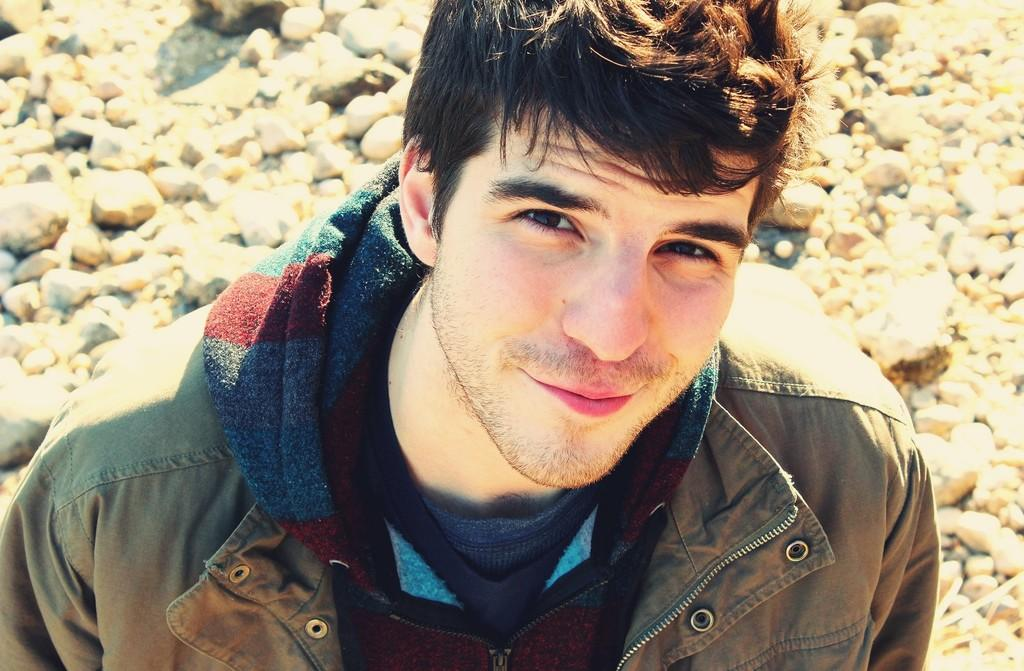Who is present in the image? There is a man in the image. What is the man doing in the image? The man is standing on the ground. What expression does the man have in the image? The man is smiling. What is the man wearing in the image? The man is wearing a jacket. What can be seen in the background of the image? There are stones visible in the background of the image. What type of railway can be seen in the image? There is no railway present in the image. What is the man competing against in the image? There is no competition depicted in the image; the man is simply standing and smiling. 